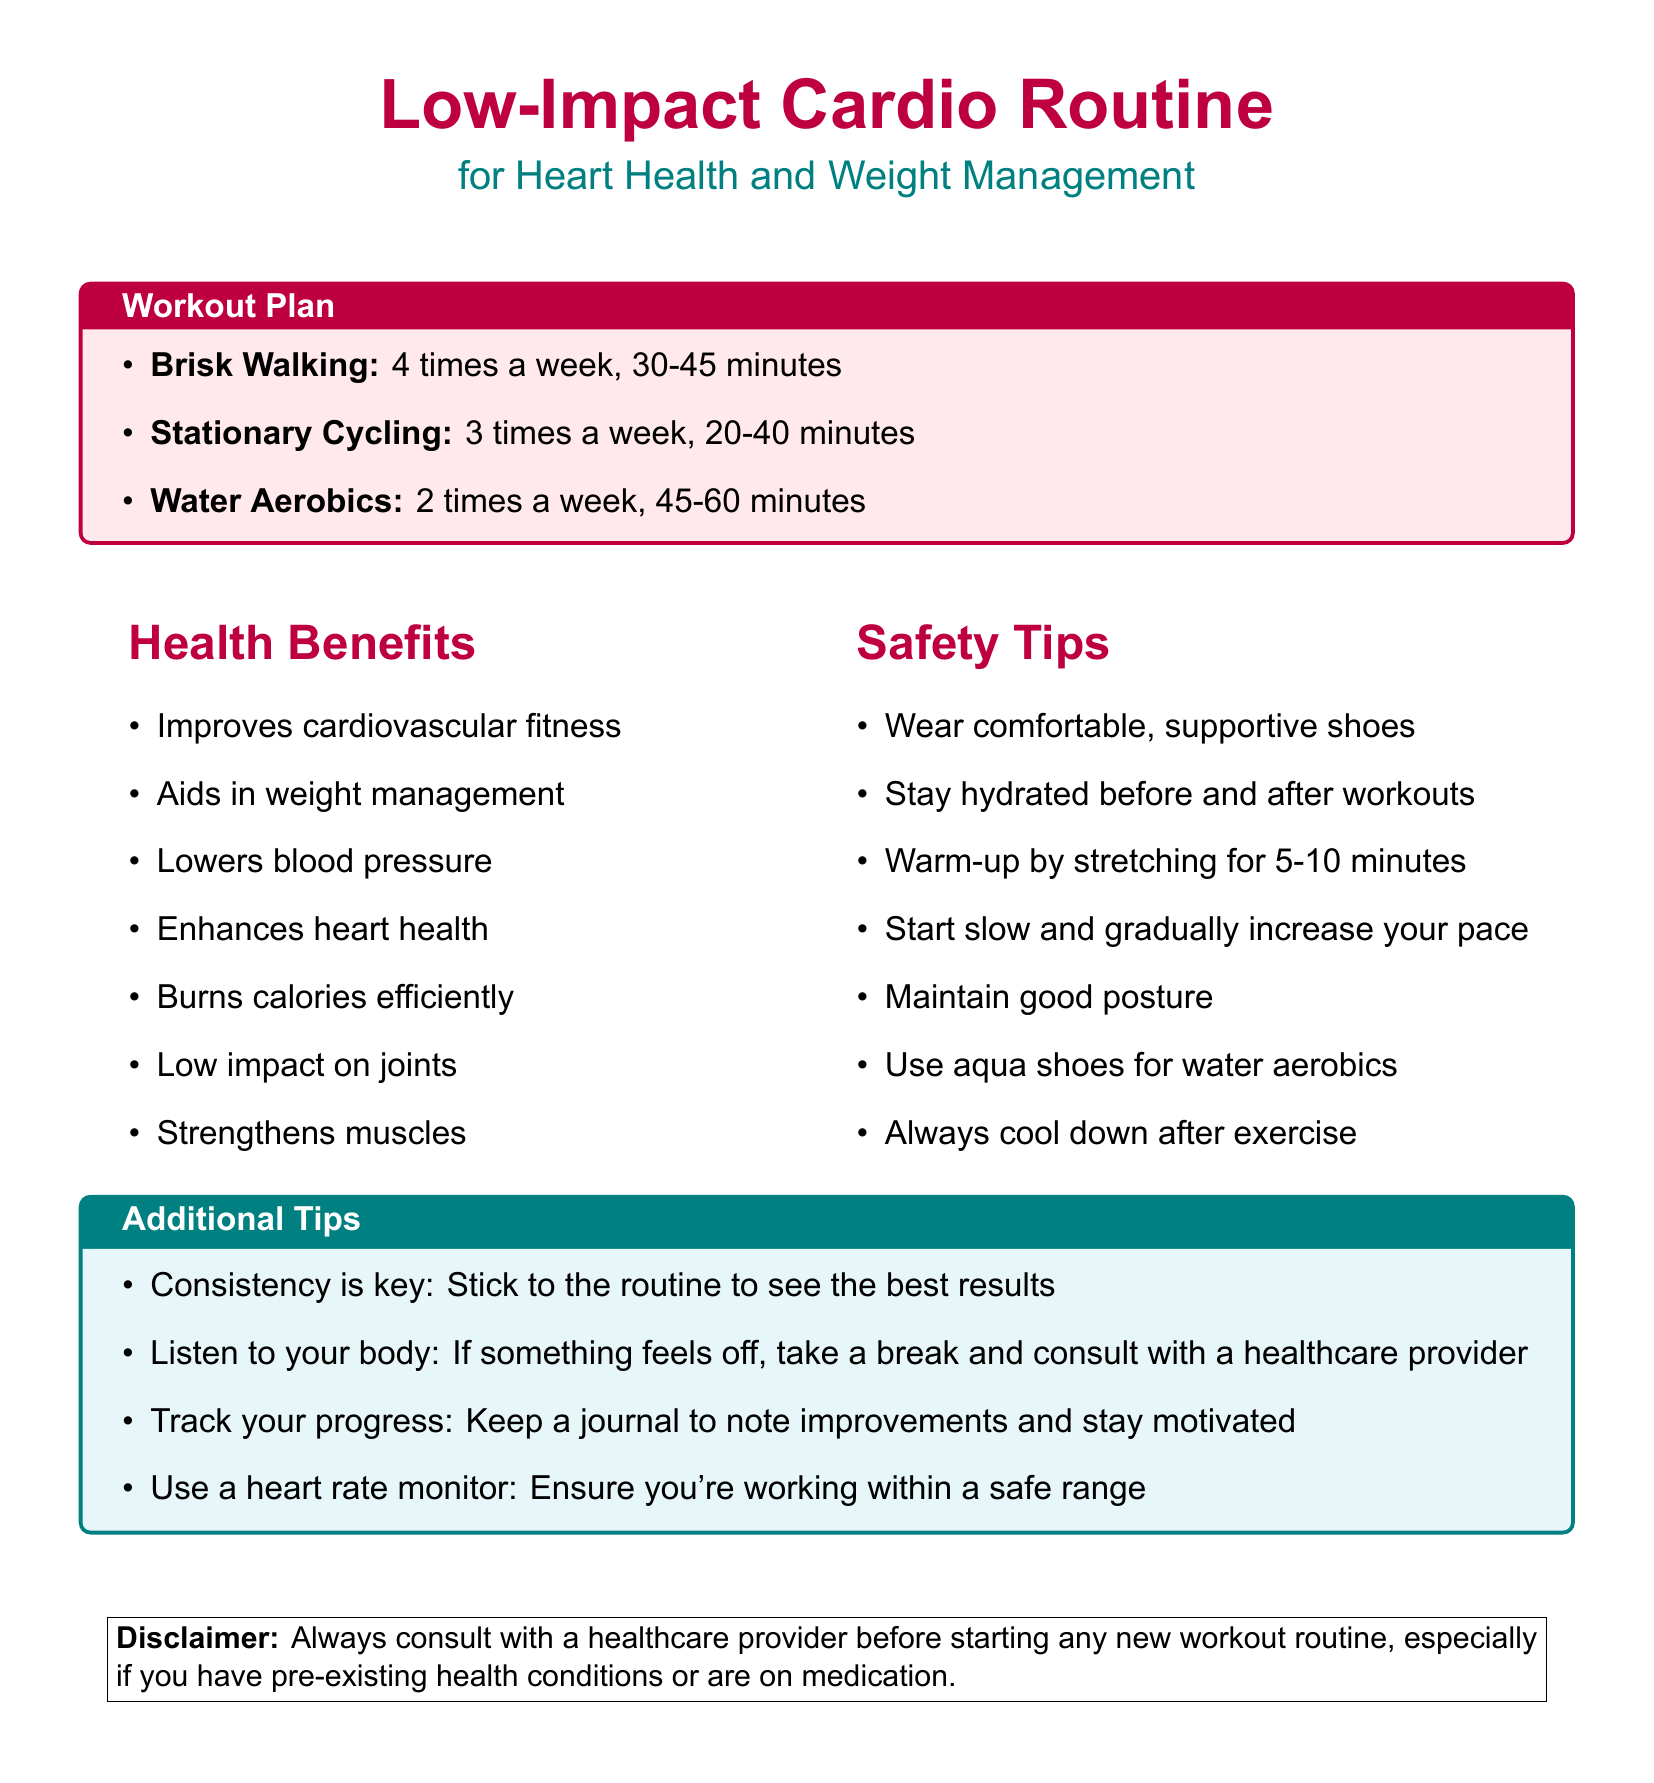What is the frequency for brisk walking? The document specifies that brisk walking should be done 4 times a week.
Answer: 4 times a week What is the duration range for stationary cycling? The document states that stationary cycling should last between 20-40 minutes.
Answer: 20-40 minutes What health benefit is associated with this workout routine? The document lists several health benefits, one of which is improving cardiovascular fitness.
Answer: Improves cardiovascular fitness What safety tip is recommended before starting workouts? The document advises to warm-up by stretching for 5-10 minutes before exercising.
Answer: Warm-up by stretching for 5-10 minutes How many times per week should water aerobics be done? According to the document, water aerobics should be performed 2 times a week.
Answer: 2 times a week What type of shoes should be worn for exercise? The document recommends wearing comfortable, supportive shoes during workouts.
Answer: Comfortable, supportive shoes What is the key to achieving the best results according to additional tips? The document emphasizes that consistency is key to seeing the best results.
Answer: Consistency is key What should you do if something feels off during exercise? The document suggests taking a break and consulting with a healthcare provider if something feels off.
Answer: Take a break and consult with a healthcare provider 